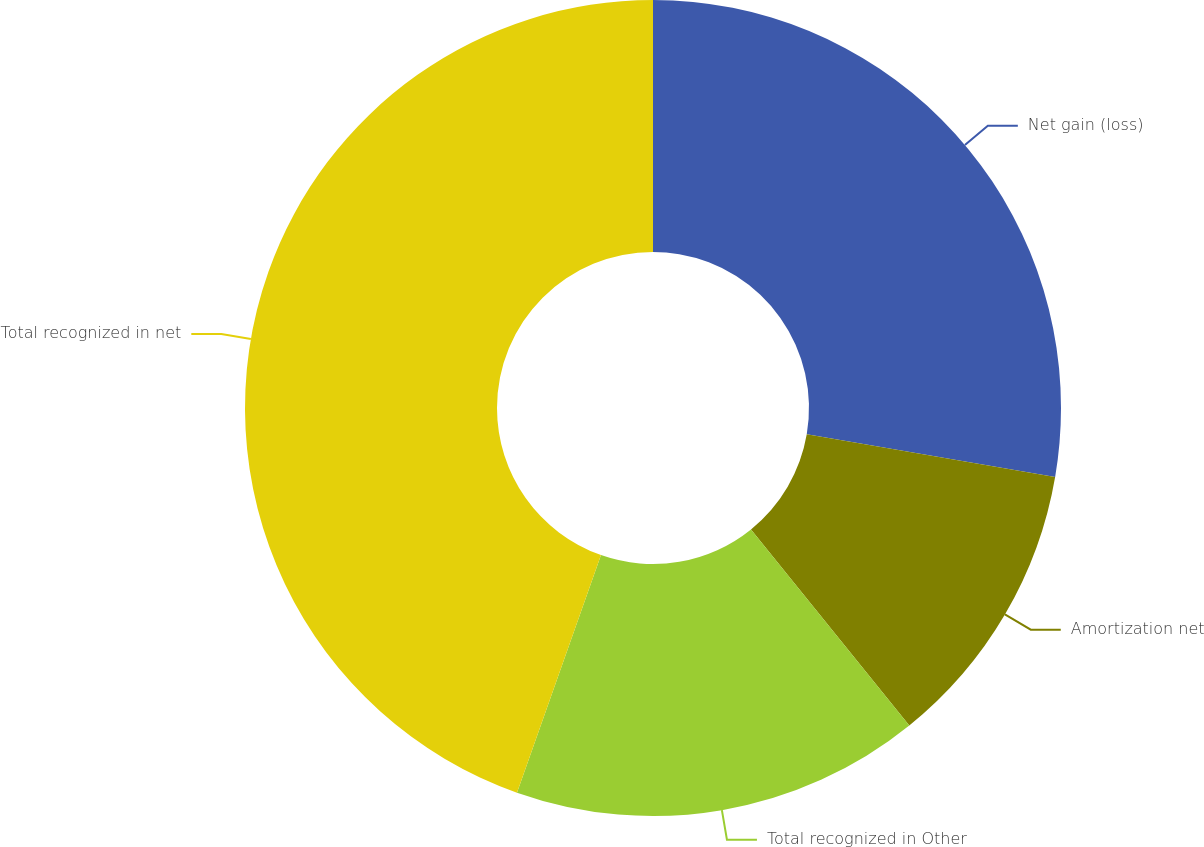Convert chart. <chart><loc_0><loc_0><loc_500><loc_500><pie_chart><fcel>Net gain (loss)<fcel>Amortization net<fcel>Total recognized in Other<fcel>Total recognized in net<nl><fcel>27.7%<fcel>11.49%<fcel>16.22%<fcel>44.59%<nl></chart> 